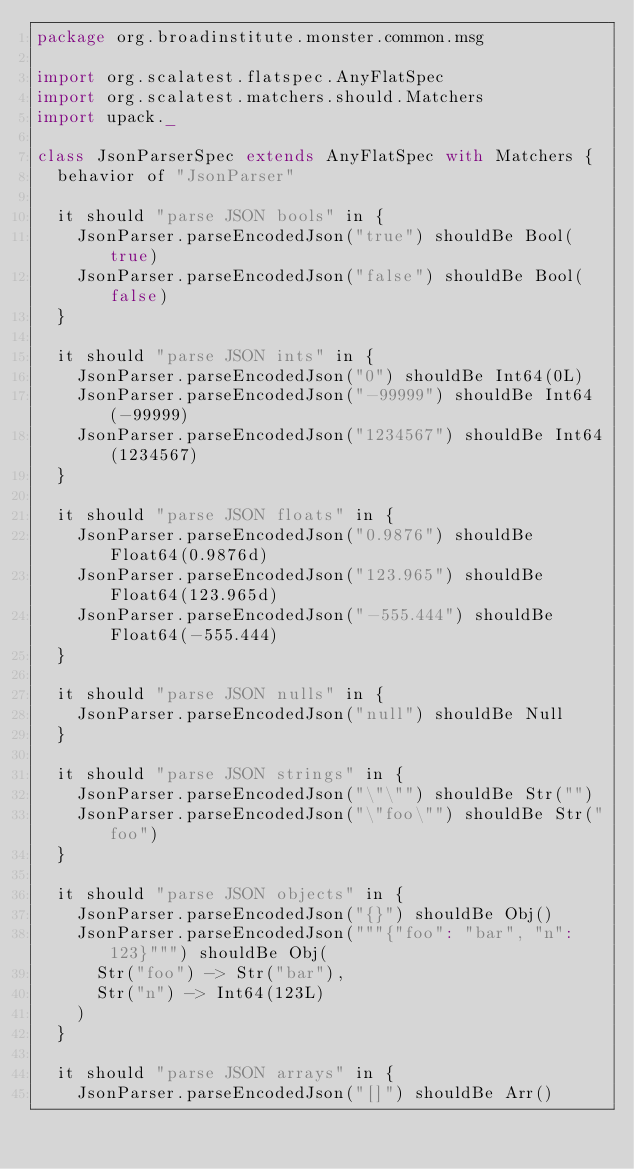Convert code to text. <code><loc_0><loc_0><loc_500><loc_500><_Scala_>package org.broadinstitute.monster.common.msg

import org.scalatest.flatspec.AnyFlatSpec
import org.scalatest.matchers.should.Matchers
import upack._

class JsonParserSpec extends AnyFlatSpec with Matchers {
  behavior of "JsonParser"

  it should "parse JSON bools" in {
    JsonParser.parseEncodedJson("true") shouldBe Bool(true)
    JsonParser.parseEncodedJson("false") shouldBe Bool(false)
  }

  it should "parse JSON ints" in {
    JsonParser.parseEncodedJson("0") shouldBe Int64(0L)
    JsonParser.parseEncodedJson("-99999") shouldBe Int64(-99999)
    JsonParser.parseEncodedJson("1234567") shouldBe Int64(1234567)
  }

  it should "parse JSON floats" in {
    JsonParser.parseEncodedJson("0.9876") shouldBe Float64(0.9876d)
    JsonParser.parseEncodedJson("123.965") shouldBe Float64(123.965d)
    JsonParser.parseEncodedJson("-555.444") shouldBe Float64(-555.444)
  }

  it should "parse JSON nulls" in {
    JsonParser.parseEncodedJson("null") shouldBe Null
  }

  it should "parse JSON strings" in {
    JsonParser.parseEncodedJson("\"\"") shouldBe Str("")
    JsonParser.parseEncodedJson("\"foo\"") shouldBe Str("foo")
  }

  it should "parse JSON objects" in {
    JsonParser.parseEncodedJson("{}") shouldBe Obj()
    JsonParser.parseEncodedJson("""{"foo": "bar", "n": 123}""") shouldBe Obj(
      Str("foo") -> Str("bar"),
      Str("n") -> Int64(123L)
    )
  }

  it should "parse JSON arrays" in {
    JsonParser.parseEncodedJson("[]") shouldBe Arr()</code> 